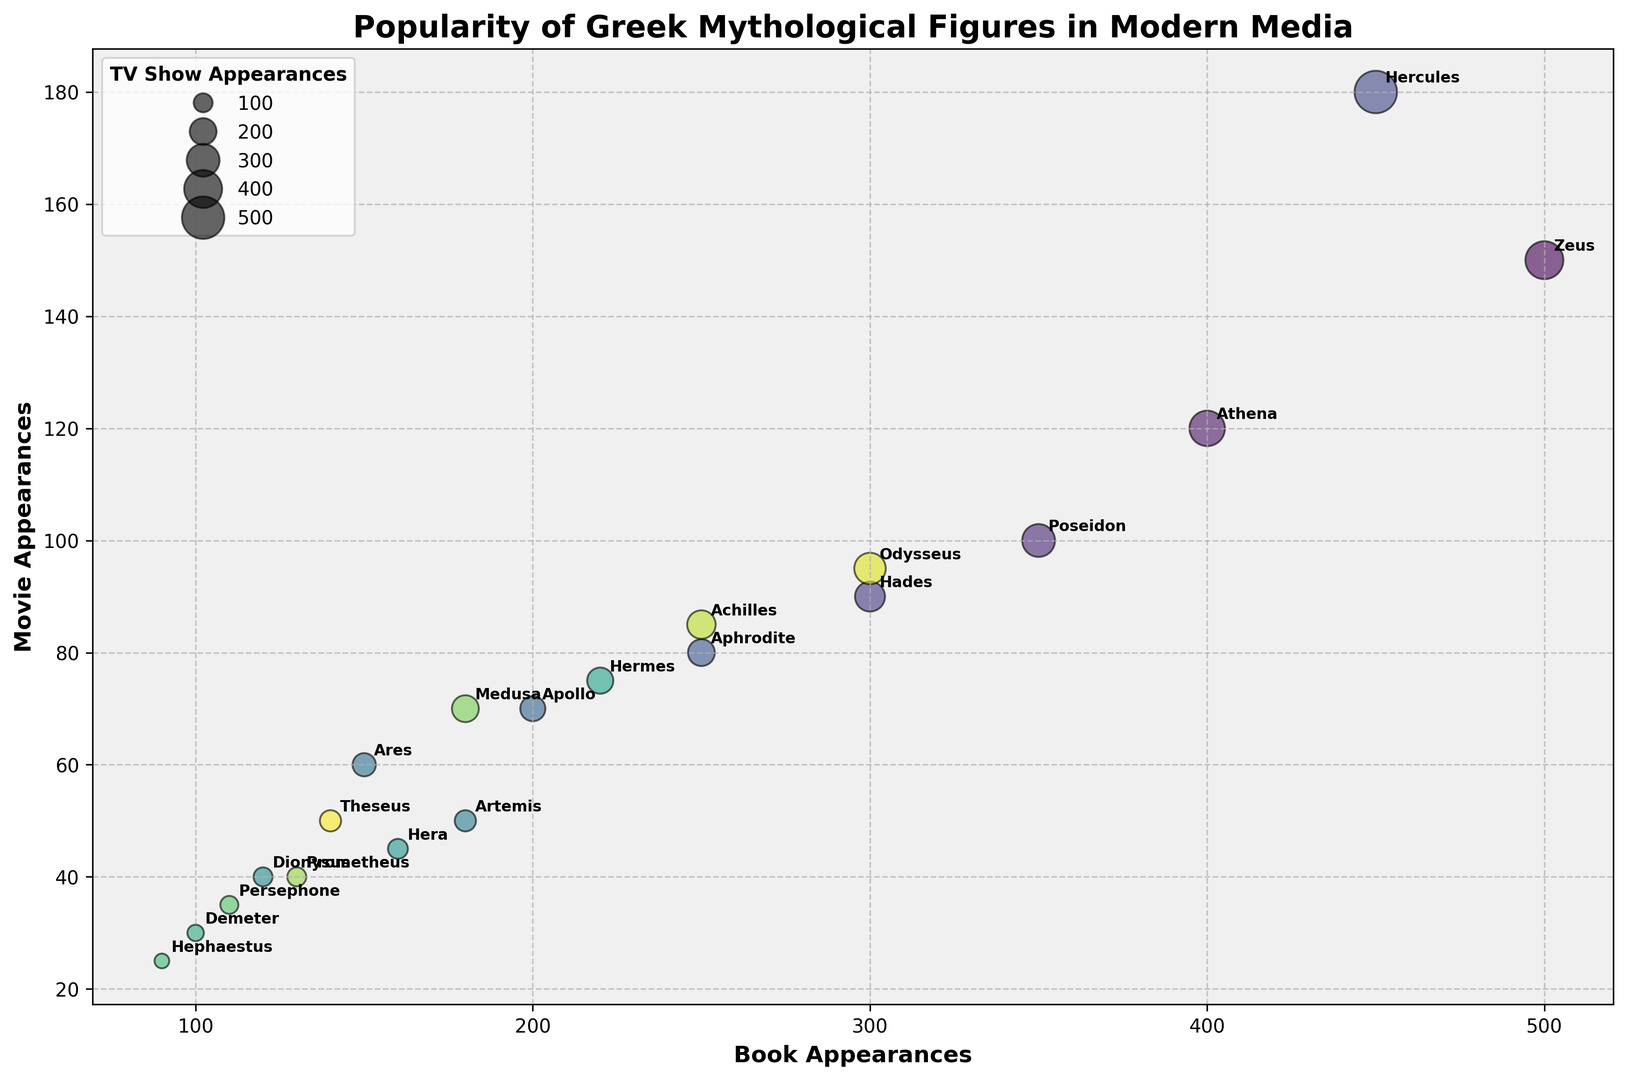What's the figure with the most appearances in TV shows? Look at the sizes of the bubbles, which indicate TV show appearances. The largest bubbles are labeled "Zeus" and "Hercules", both have 100 TV show appearances.
Answer: Zeus and Hercules Which figure has more movie appearances: Athena or Poseidon? Compare the y-axis values for Athena and Poseidon. Athena has 120 movie appearances, while Poseidon has 100.
Answer: Athena What's the total number of appearances for Aphrodite across books, movies, and TV shows? Add up book, movie, and TV show appearances for Aphrodite: 250 + 80 + 40 = 370.
Answer: 370 Which figure has the highest total appearances in books? Look at the x-axis (Book Appearances). Both Zeus and Hercules have 500 book appearances.
Answer: Zeus and Hercules Who is more popular in movies compared to TV shows: Medusa or Apollo? Compare movie to TV show appearances for both. Medusa: 70 (movie) vs 40 (TV), Apollo: 70 (movie) vs 35 (TV). Medusa has a higher ratio of movie appearances to TV shows.
Answer: Medusa Who is less represented in books compared to movies: Hephaestus or Hera? Compare book to movie appearances for both. Hephaestus: 90 (book) vs 25 (movie), Hera: 160 (book) vs 45 (movie). Hephaestus has a lower proportion of book appearances compared to movies.
Answer: Hephaestus How many figures have more than 300 total appearances? Check the figures with total appearances greater than 300. These are Zeus, Athena, Poseidon, Hades, Hercules, Apollo, Medusa, and Odysseus. There are 8.
Answer: 8 What is the sum of TV show appearances for all figures? Add up TV show appearances for all figures: 80 + 70 + 60 + 50 + 40 + 35 + 30 + 25 + 20 + 22 + 38 + 15 + 12 + 18 + 40 + 20 + 45 + 25 = 735.
Answer: 735 Which two figures have similar total appearances in media? Compare the total appearances. Zeus and Hercules both have 730 total appearances.
Answer: Zeus and Hercules 